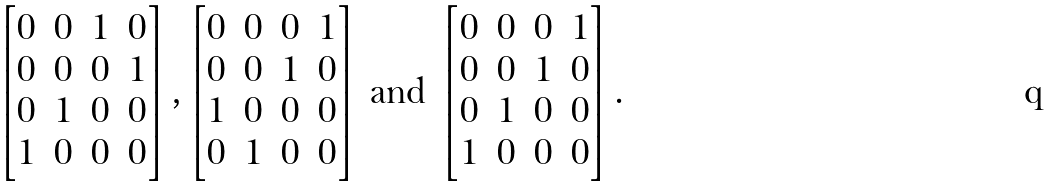Convert formula to latex. <formula><loc_0><loc_0><loc_500><loc_500>\begin{bmatrix} 0 & 0 & 1 & 0 \\ 0 & 0 & 0 & 1 \\ 0 & 1 & 0 & 0 \\ 1 & 0 & 0 & 0 \end{bmatrix} , \begin{bmatrix} 0 & 0 & 0 & 1 \\ 0 & 0 & 1 & 0 \\ 1 & 0 & 0 & 0 \\ 0 & 1 & 0 & 0 \end{bmatrix} \text { and } \begin{bmatrix} 0 & 0 & 0 & 1 \\ 0 & 0 & 1 & 0 \\ 0 & 1 & 0 & 0 \\ 1 & 0 & 0 & 0 \end{bmatrix} .</formula> 